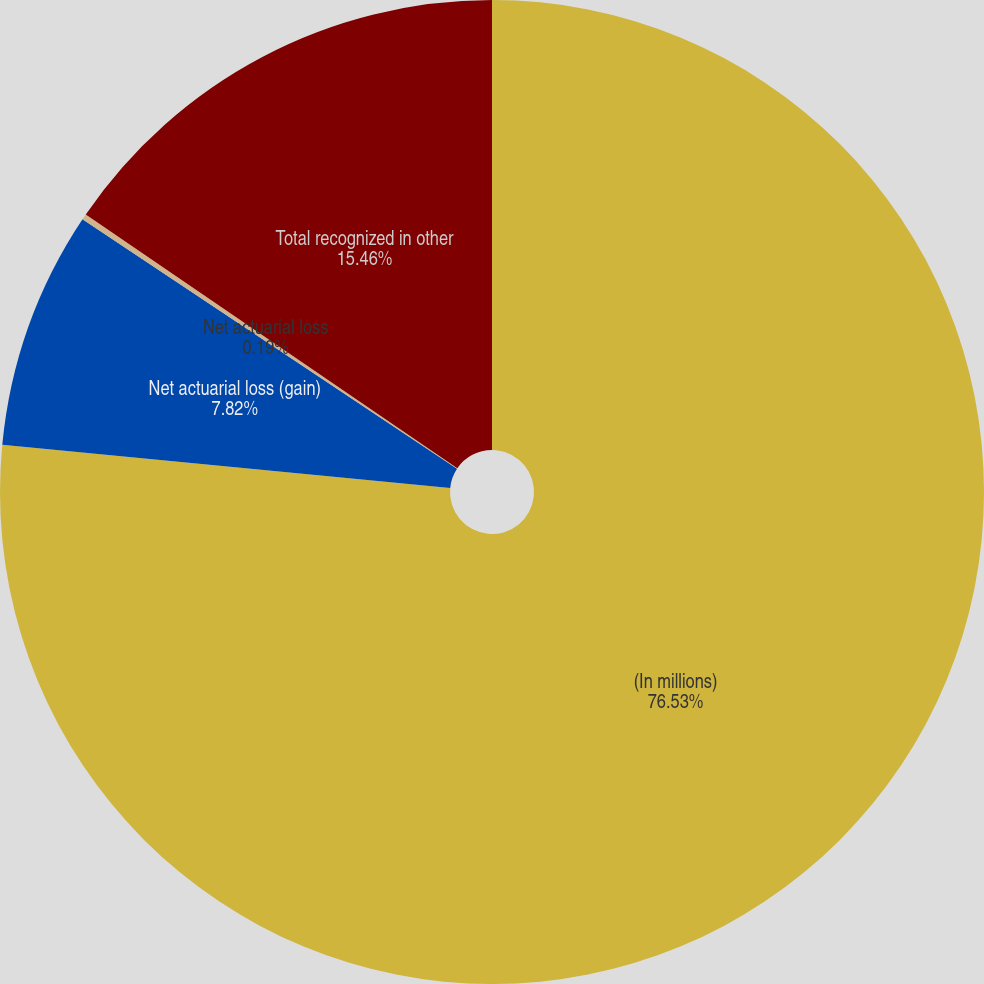Convert chart. <chart><loc_0><loc_0><loc_500><loc_500><pie_chart><fcel>(In millions)<fcel>Net actuarial loss (gain)<fcel>Net actuarial loss<fcel>Total recognized in other<nl><fcel>76.53%<fcel>7.82%<fcel>0.19%<fcel>15.46%<nl></chart> 